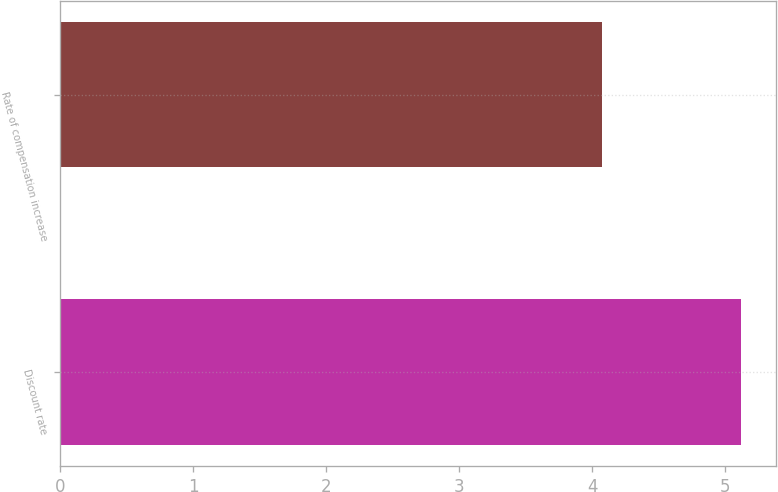Convert chart to OTSL. <chart><loc_0><loc_0><loc_500><loc_500><bar_chart><fcel>Discount rate<fcel>Rate of compensation increase<nl><fcel>5.12<fcel>4.07<nl></chart> 